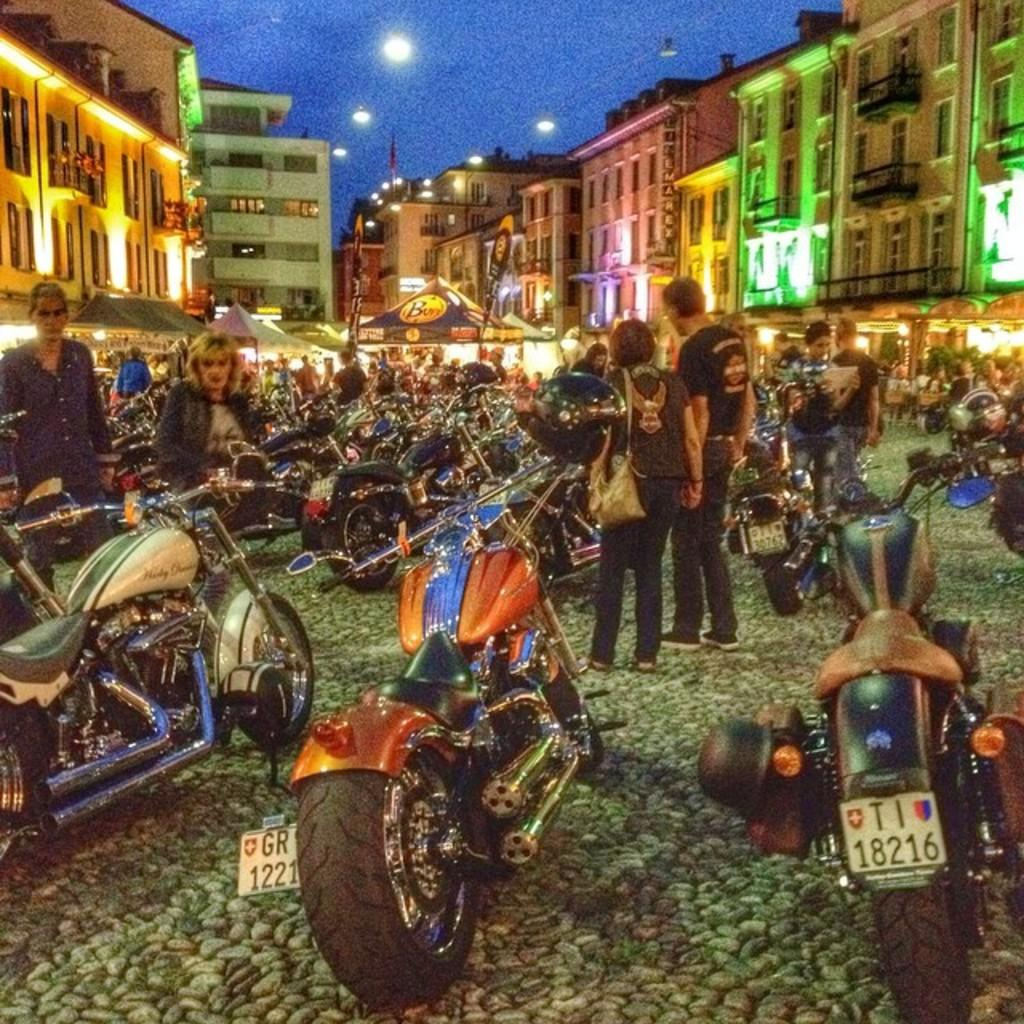What type of vehicles are present in the image? There are motorbikes in the image. What is the status of the motorbikes in the image? The motorbikes are parked. Are there any people visible in the image? Yes, there are people standing in the image. What type of structures can be seen in the background of the image? There are buildings with windows in the image. What type of lighting is present in the image? There are street lights in the image. What additional structures are present in the image? There are canopy tents in the image. Where is the hydrant located in the image? There is no hydrant present in the image. What type of weapon is being fired by the beggar in the image? There is no beggar or weapon present in the image. 